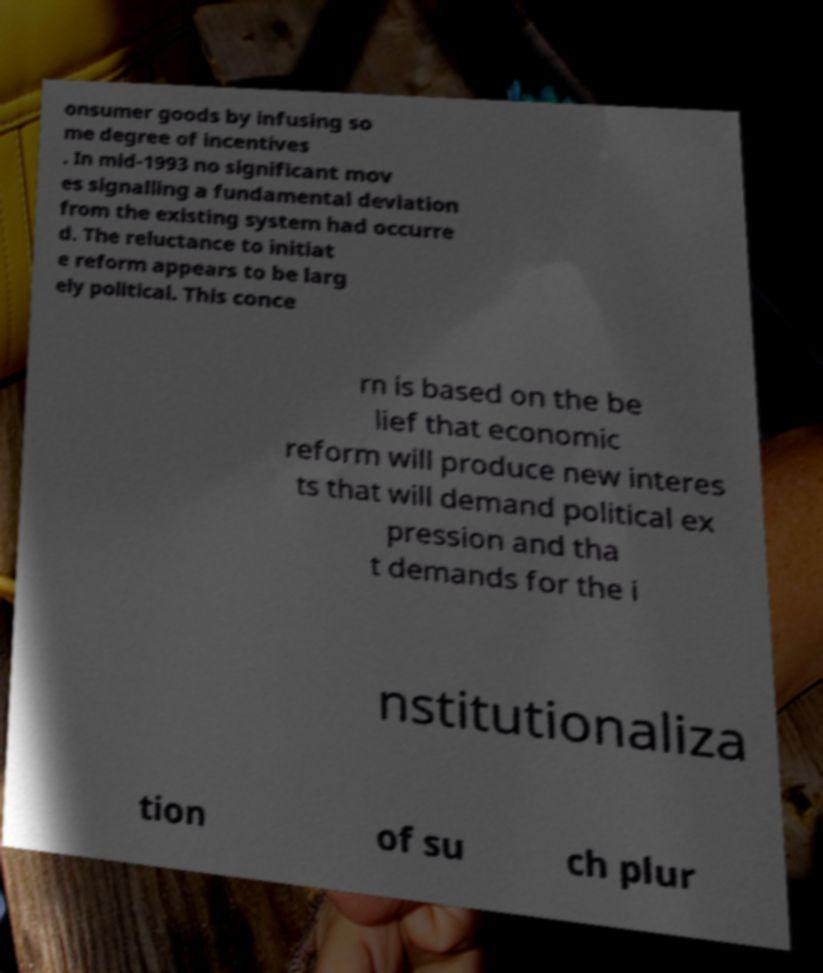There's text embedded in this image that I need extracted. Can you transcribe it verbatim? onsumer goods by infusing so me degree of incentives . In mid-1993 no significant mov es signalling a fundamental deviation from the existing system had occurre d. The reluctance to initiat e reform appears to be larg ely political. This conce rn is based on the be lief that economic reform will produce new interes ts that will demand political ex pression and tha t demands for the i nstitutionaliza tion of su ch plur 